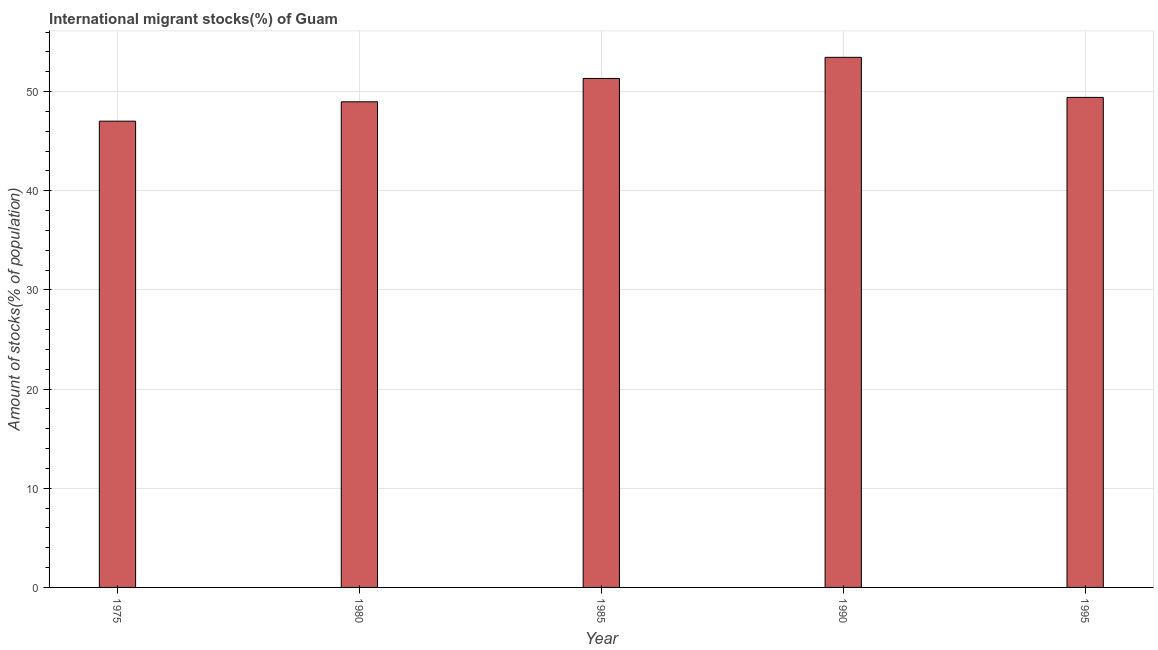Does the graph contain any zero values?
Keep it short and to the point. No. What is the title of the graph?
Make the answer very short. International migrant stocks(%) of Guam. What is the label or title of the Y-axis?
Make the answer very short. Amount of stocks(% of population). What is the number of international migrant stocks in 1985?
Your answer should be very brief. 51.33. Across all years, what is the maximum number of international migrant stocks?
Your answer should be very brief. 53.46. Across all years, what is the minimum number of international migrant stocks?
Give a very brief answer. 47.02. In which year was the number of international migrant stocks maximum?
Give a very brief answer. 1990. In which year was the number of international migrant stocks minimum?
Make the answer very short. 1975. What is the sum of the number of international migrant stocks?
Keep it short and to the point. 250.2. What is the difference between the number of international migrant stocks in 1975 and 1990?
Ensure brevity in your answer.  -6.44. What is the average number of international migrant stocks per year?
Provide a short and direct response. 50.04. What is the median number of international migrant stocks?
Your answer should be compact. 49.42. In how many years, is the number of international migrant stocks greater than 26 %?
Your answer should be very brief. 5. Is the number of international migrant stocks in 1985 less than that in 1990?
Your response must be concise. Yes. Is the difference between the number of international migrant stocks in 1975 and 1990 greater than the difference between any two years?
Your answer should be compact. Yes. What is the difference between the highest and the second highest number of international migrant stocks?
Your answer should be compact. 2.13. Is the sum of the number of international migrant stocks in 1980 and 1990 greater than the maximum number of international migrant stocks across all years?
Offer a terse response. Yes. What is the difference between the highest and the lowest number of international migrant stocks?
Provide a short and direct response. 6.44. In how many years, is the number of international migrant stocks greater than the average number of international migrant stocks taken over all years?
Your answer should be compact. 2. How many bars are there?
Provide a succinct answer. 5. How many years are there in the graph?
Give a very brief answer. 5. What is the difference between two consecutive major ticks on the Y-axis?
Your response must be concise. 10. What is the Amount of stocks(% of population) of 1975?
Give a very brief answer. 47.02. What is the Amount of stocks(% of population) in 1980?
Your response must be concise. 48.97. What is the Amount of stocks(% of population) of 1985?
Your answer should be compact. 51.33. What is the Amount of stocks(% of population) of 1990?
Your answer should be very brief. 53.46. What is the Amount of stocks(% of population) in 1995?
Your answer should be very brief. 49.42. What is the difference between the Amount of stocks(% of population) in 1975 and 1980?
Your answer should be compact. -1.95. What is the difference between the Amount of stocks(% of population) in 1975 and 1985?
Ensure brevity in your answer.  -4.31. What is the difference between the Amount of stocks(% of population) in 1975 and 1990?
Give a very brief answer. -6.44. What is the difference between the Amount of stocks(% of population) in 1975 and 1995?
Offer a terse response. -2.4. What is the difference between the Amount of stocks(% of population) in 1980 and 1985?
Make the answer very short. -2.35. What is the difference between the Amount of stocks(% of population) in 1980 and 1990?
Offer a very short reply. -4.49. What is the difference between the Amount of stocks(% of population) in 1980 and 1995?
Keep it short and to the point. -0.44. What is the difference between the Amount of stocks(% of population) in 1985 and 1990?
Give a very brief answer. -2.13. What is the difference between the Amount of stocks(% of population) in 1985 and 1995?
Provide a succinct answer. 1.91. What is the difference between the Amount of stocks(% of population) in 1990 and 1995?
Your response must be concise. 4.04. What is the ratio of the Amount of stocks(% of population) in 1975 to that in 1980?
Your answer should be compact. 0.96. What is the ratio of the Amount of stocks(% of population) in 1975 to that in 1985?
Provide a succinct answer. 0.92. What is the ratio of the Amount of stocks(% of population) in 1975 to that in 1990?
Make the answer very short. 0.88. What is the ratio of the Amount of stocks(% of population) in 1980 to that in 1985?
Your answer should be very brief. 0.95. What is the ratio of the Amount of stocks(% of population) in 1980 to that in 1990?
Keep it short and to the point. 0.92. What is the ratio of the Amount of stocks(% of population) in 1980 to that in 1995?
Give a very brief answer. 0.99. What is the ratio of the Amount of stocks(% of population) in 1985 to that in 1995?
Keep it short and to the point. 1.04. What is the ratio of the Amount of stocks(% of population) in 1990 to that in 1995?
Your answer should be very brief. 1.08. 